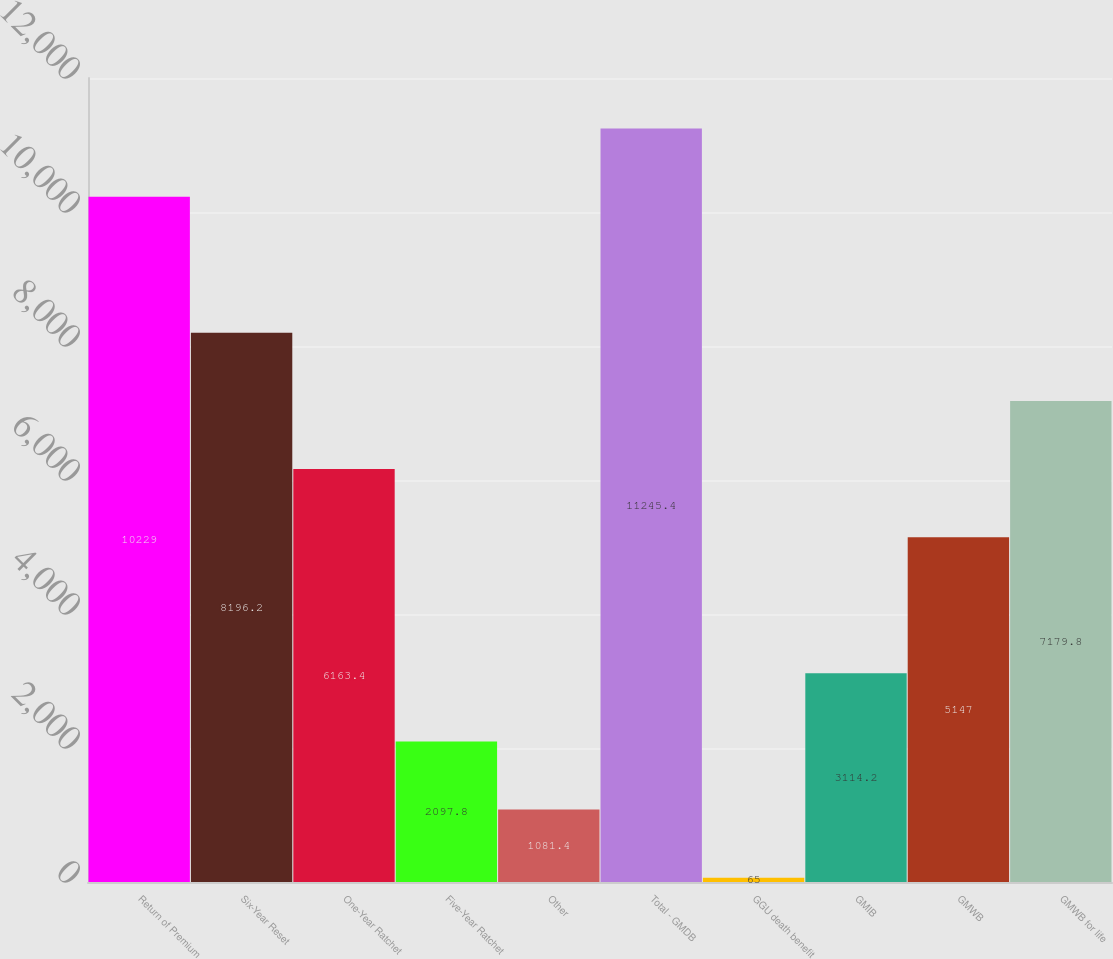Convert chart. <chart><loc_0><loc_0><loc_500><loc_500><bar_chart><fcel>Return of Premium<fcel>Six-Year Reset<fcel>One-Year Ratchet<fcel>Five-Year Ratchet<fcel>Other<fcel>Total - GMDB<fcel>GGU death benefit<fcel>GMIB<fcel>GMWB<fcel>GMWB for life<nl><fcel>10229<fcel>8196.2<fcel>6163.4<fcel>2097.8<fcel>1081.4<fcel>11245.4<fcel>65<fcel>3114.2<fcel>5147<fcel>7179.8<nl></chart> 